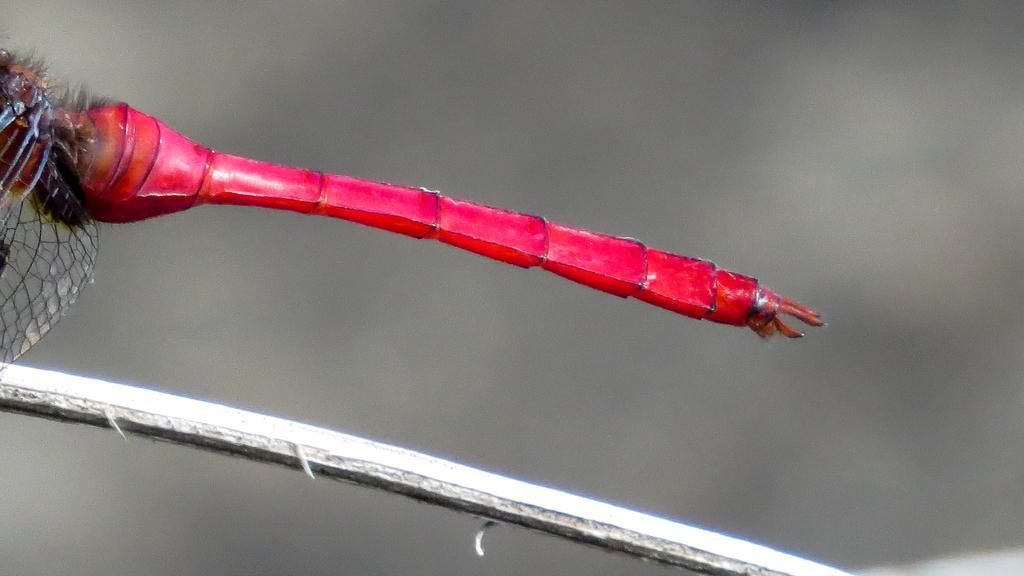In one or two sentences, can you explain what this image depicts? In the center of the image we can see one stick. On the stick, we can see one dragonfly, which is in red color. 